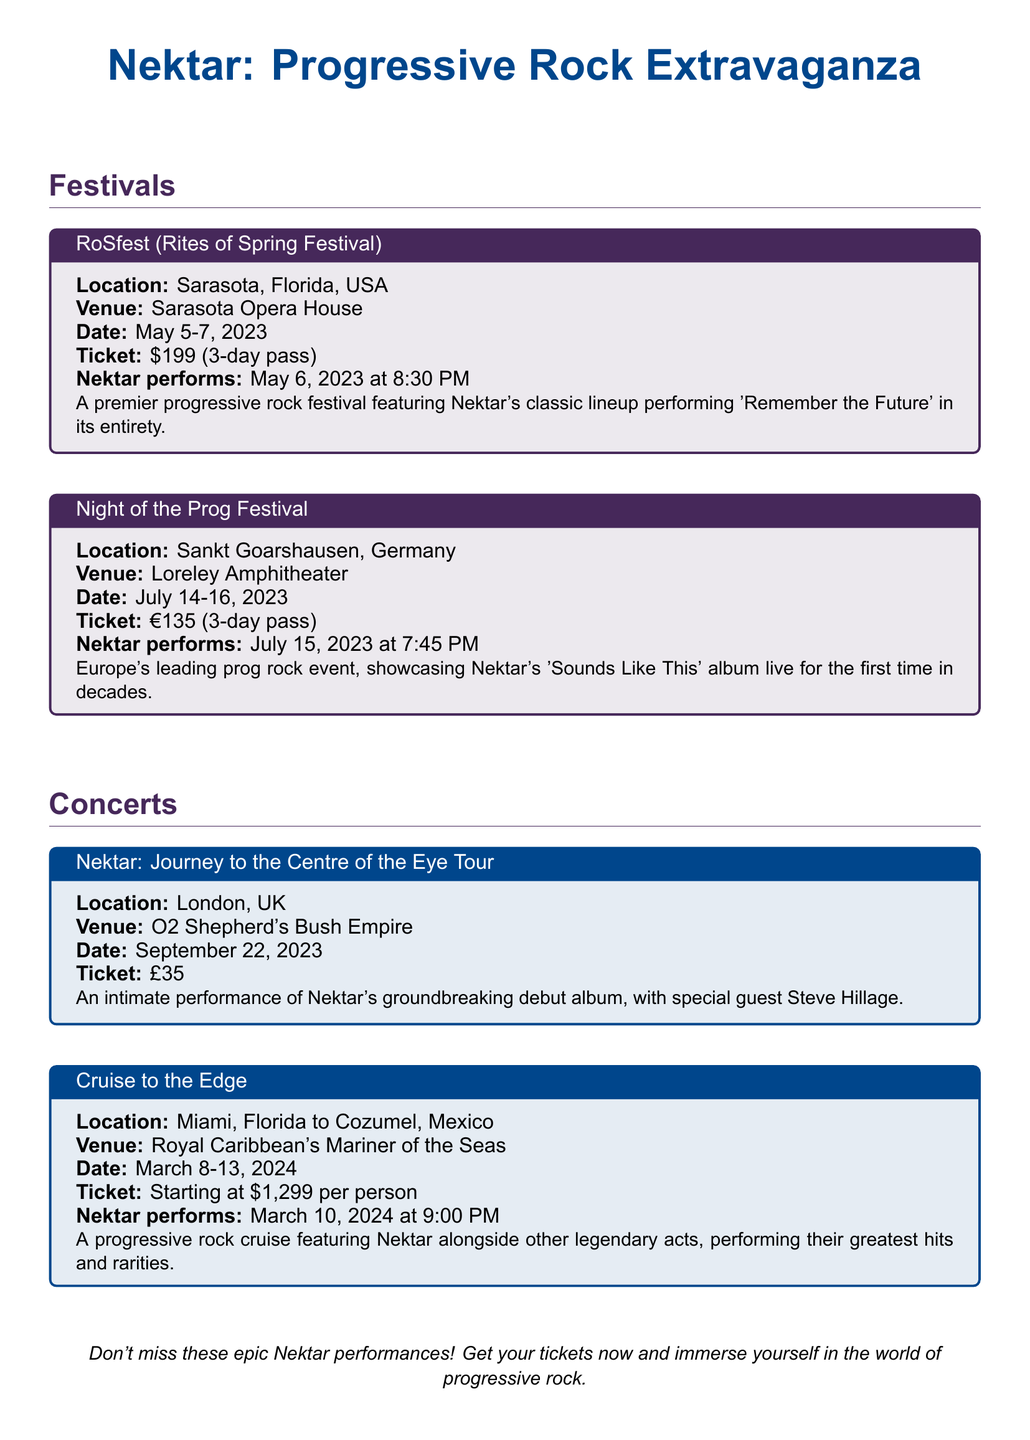What is the location of RoSfest? RoSfest takes place in Sarasota, Florida, USA, as mentioned in the document.
Answer: Sarasota, Florida, USA When does Nektar perform at Night of the Prog Festival? Nektar's performance at Night of the Prog Festival is scheduled for July 15, 2023, according to the details provided.
Answer: July 15, 2023 What is the ticket price for the Cruise to the Edge event? The ticket price for the Cruise to the Edge event is starting at \$1,299 per person, as stated in the document.
Answer: Starting at \$1,299 What is the title of Nektar's performance in London? The performance in London is titled "Nektar: Journey to the Centre of the Eye Tour," which is specified in the concert section.
Answer: Nektar: Journey to the Centre of the Eye Tour How many days does the RoSfest pass cover? The RoSfest ticket is a 3-day pass as noted in the festival box.
Answer: 3-day pass What special guest is performing with Nektar in London? The document indicates that Steve Hillage is the special guest performing with Nektar in London.
Answer: Steve Hillage Where is Night of the Prog Festival held? Night of the Prog Festival is held at the Loreley Amphitheater, as mentioned in the festival details.
Answer: Loreley Amphitheater What is Nektar's performance time at RoSfest? Nektar performs at RoSfest at 8:30 PM on May 6, 2023, according to the festival information.
Answer: 8:30 PM 